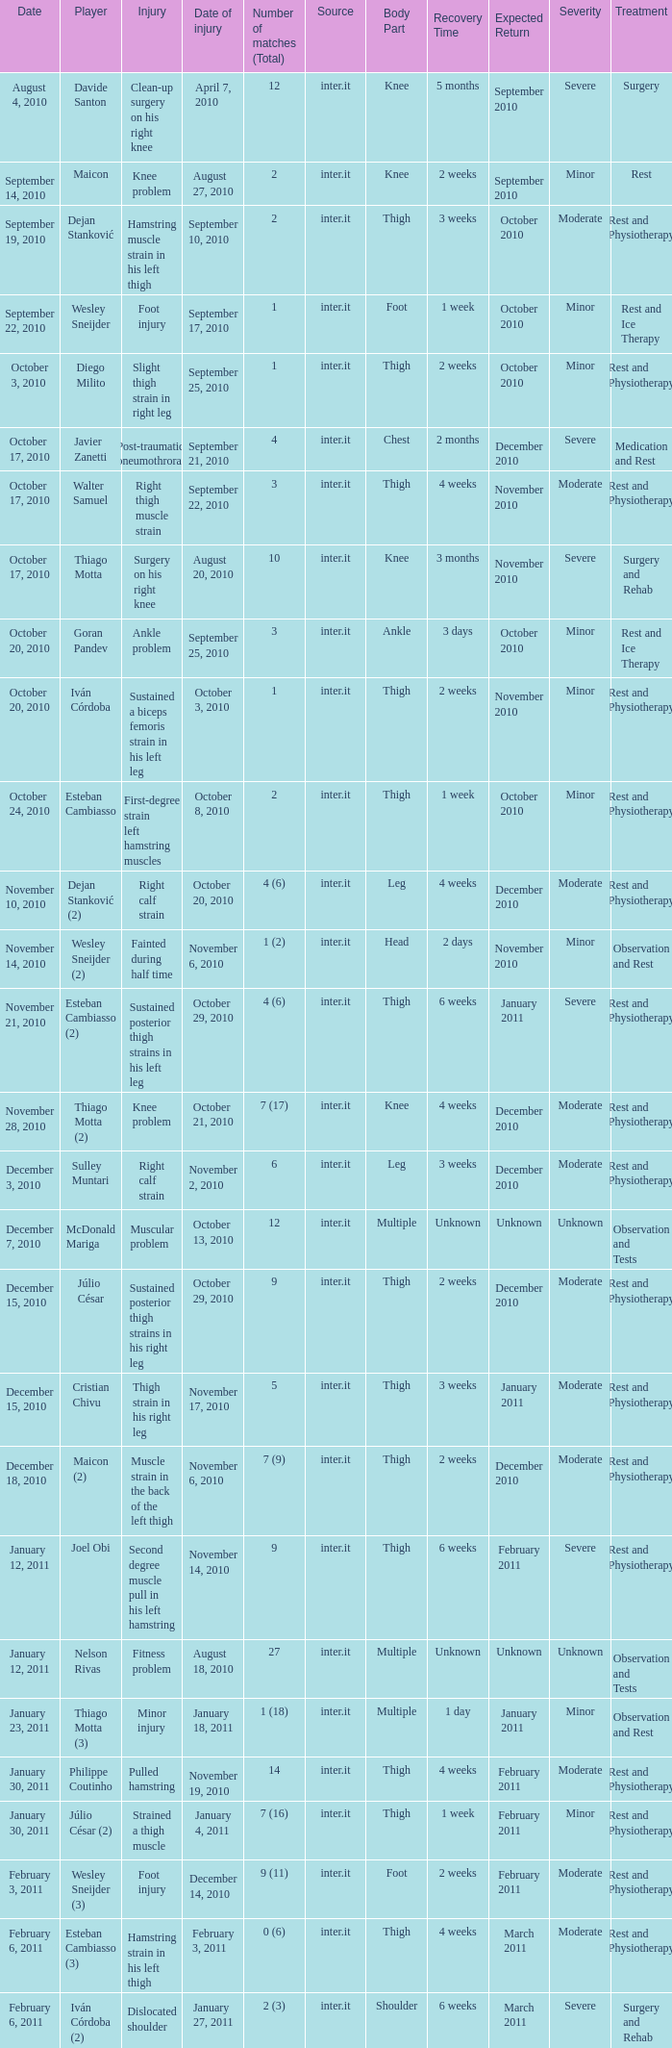What is the date of injury when the injury is sustained posterior thigh strains in his left leg? October 29, 2010. 